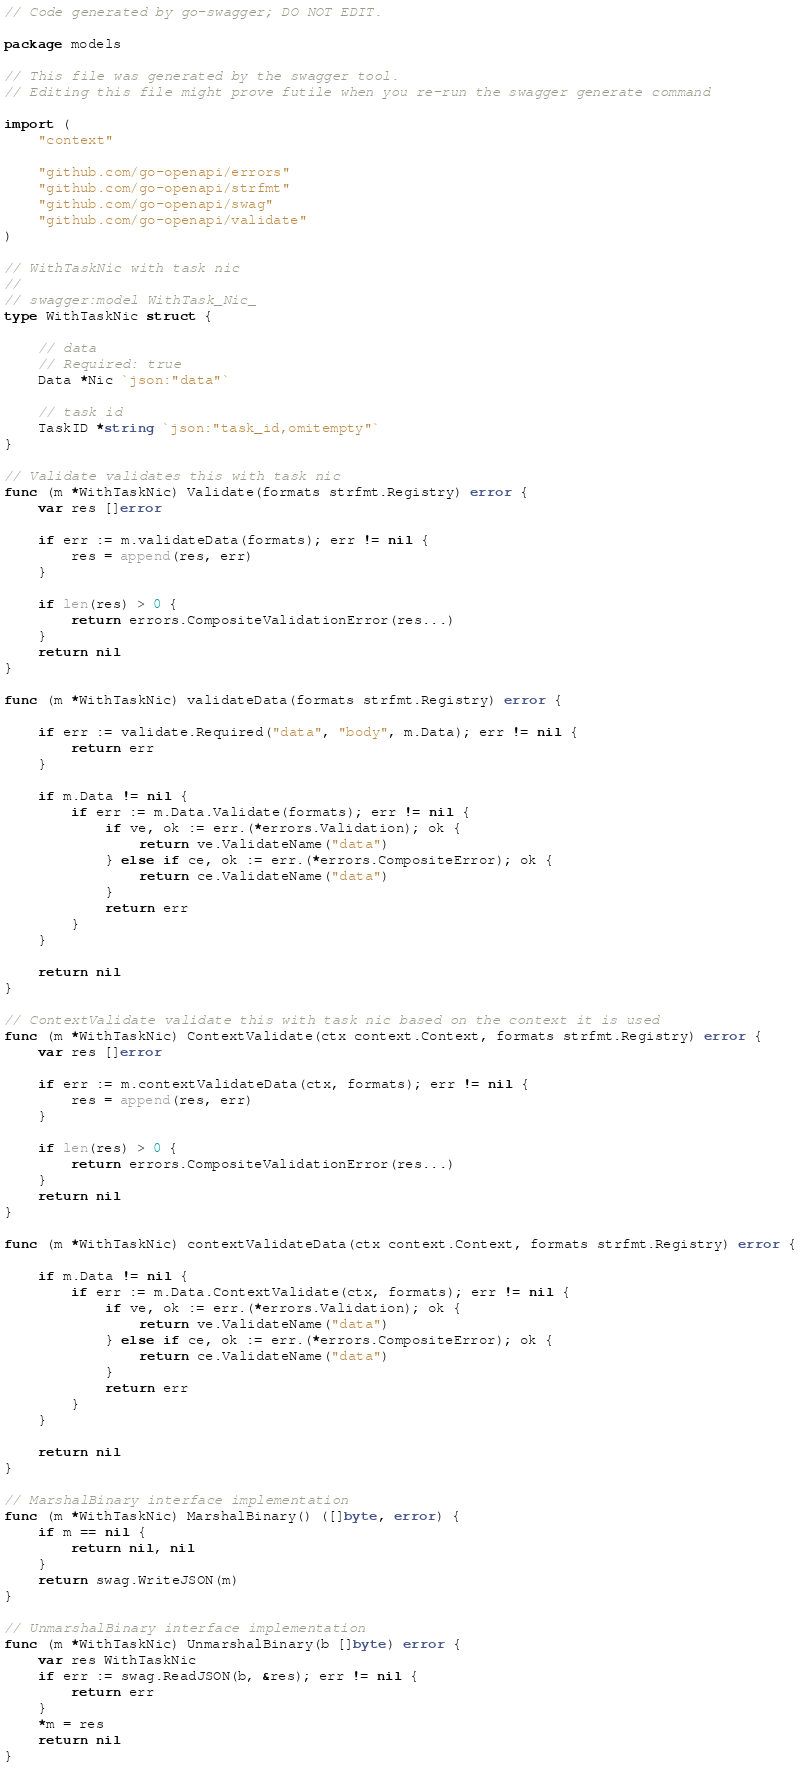Convert code to text. <code><loc_0><loc_0><loc_500><loc_500><_Go_>// Code generated by go-swagger; DO NOT EDIT.

package models

// This file was generated by the swagger tool.
// Editing this file might prove futile when you re-run the swagger generate command

import (
	"context"

	"github.com/go-openapi/errors"
	"github.com/go-openapi/strfmt"
	"github.com/go-openapi/swag"
	"github.com/go-openapi/validate"
)

// WithTaskNic with task nic
//
// swagger:model WithTask_Nic_
type WithTaskNic struct {

	// data
	// Required: true
	Data *Nic `json:"data"`

	// task id
	TaskID *string `json:"task_id,omitempty"`
}

// Validate validates this with task nic
func (m *WithTaskNic) Validate(formats strfmt.Registry) error {
	var res []error

	if err := m.validateData(formats); err != nil {
		res = append(res, err)
	}

	if len(res) > 0 {
		return errors.CompositeValidationError(res...)
	}
	return nil
}

func (m *WithTaskNic) validateData(formats strfmt.Registry) error {

	if err := validate.Required("data", "body", m.Data); err != nil {
		return err
	}

	if m.Data != nil {
		if err := m.Data.Validate(formats); err != nil {
			if ve, ok := err.(*errors.Validation); ok {
				return ve.ValidateName("data")
			} else if ce, ok := err.(*errors.CompositeError); ok {
				return ce.ValidateName("data")
			}
			return err
		}
	}

	return nil
}

// ContextValidate validate this with task nic based on the context it is used
func (m *WithTaskNic) ContextValidate(ctx context.Context, formats strfmt.Registry) error {
	var res []error

	if err := m.contextValidateData(ctx, formats); err != nil {
		res = append(res, err)
	}

	if len(res) > 0 {
		return errors.CompositeValidationError(res...)
	}
	return nil
}

func (m *WithTaskNic) contextValidateData(ctx context.Context, formats strfmt.Registry) error {

	if m.Data != nil {
		if err := m.Data.ContextValidate(ctx, formats); err != nil {
			if ve, ok := err.(*errors.Validation); ok {
				return ve.ValidateName("data")
			} else if ce, ok := err.(*errors.CompositeError); ok {
				return ce.ValidateName("data")
			}
			return err
		}
	}

	return nil
}

// MarshalBinary interface implementation
func (m *WithTaskNic) MarshalBinary() ([]byte, error) {
	if m == nil {
		return nil, nil
	}
	return swag.WriteJSON(m)
}

// UnmarshalBinary interface implementation
func (m *WithTaskNic) UnmarshalBinary(b []byte) error {
	var res WithTaskNic
	if err := swag.ReadJSON(b, &res); err != nil {
		return err
	}
	*m = res
	return nil
}
</code> 